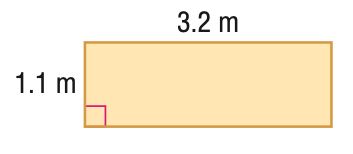Answer the mathemtical geometry problem and directly provide the correct option letter.
Question: Find the perimeter or circumference of the figure. Round to the nearest tenth.
Choices: A: 4.3 B: 8 C: 8.6 D: 17.2 C 